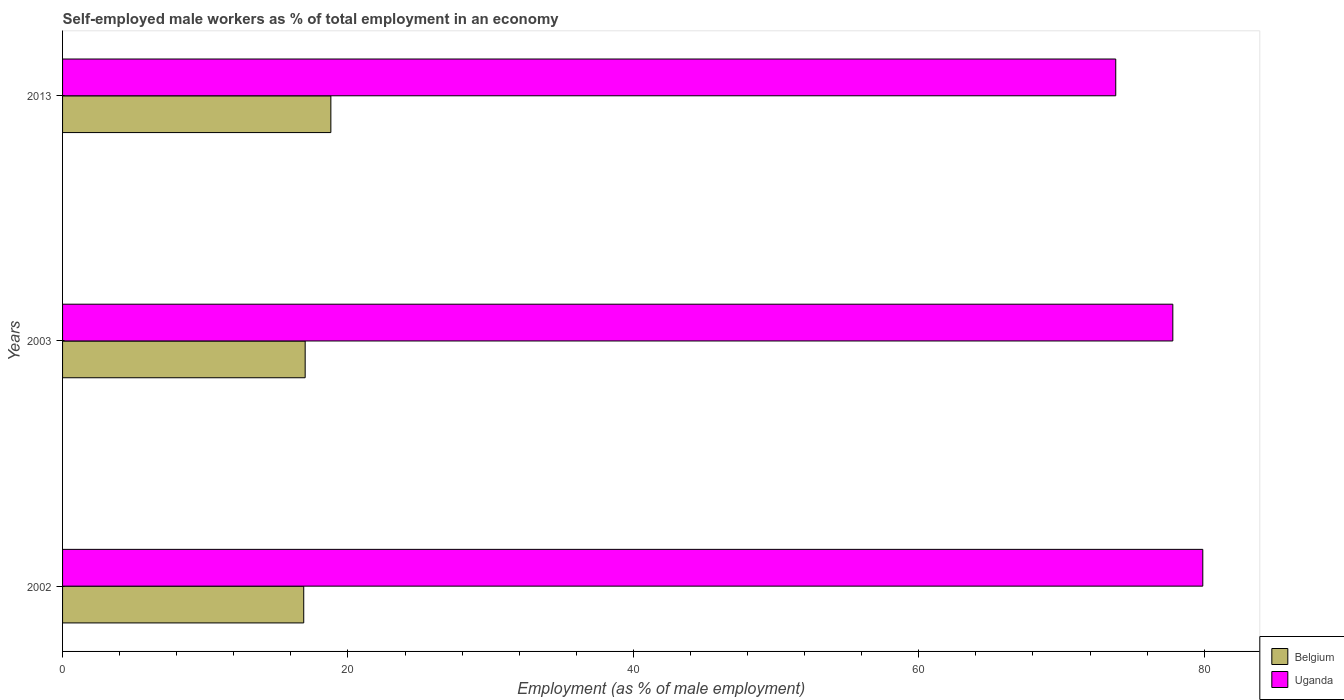How many groups of bars are there?
Ensure brevity in your answer.  3. Are the number of bars per tick equal to the number of legend labels?
Give a very brief answer. Yes. How many bars are there on the 3rd tick from the top?
Your response must be concise. 2. In how many cases, is the number of bars for a given year not equal to the number of legend labels?
Ensure brevity in your answer.  0. What is the percentage of self-employed male workers in Belgium in 2002?
Offer a terse response. 16.9. Across all years, what is the maximum percentage of self-employed male workers in Belgium?
Keep it short and to the point. 18.8. Across all years, what is the minimum percentage of self-employed male workers in Uganda?
Provide a succinct answer. 73.8. In which year was the percentage of self-employed male workers in Uganda maximum?
Offer a terse response. 2002. In which year was the percentage of self-employed male workers in Uganda minimum?
Your answer should be compact. 2013. What is the total percentage of self-employed male workers in Belgium in the graph?
Offer a very short reply. 52.7. What is the difference between the percentage of self-employed male workers in Belgium in 2003 and that in 2013?
Offer a terse response. -1.8. What is the difference between the percentage of self-employed male workers in Uganda in 2013 and the percentage of self-employed male workers in Belgium in 2002?
Make the answer very short. 56.9. What is the average percentage of self-employed male workers in Uganda per year?
Keep it short and to the point. 77.17. In the year 2003, what is the difference between the percentage of self-employed male workers in Uganda and percentage of self-employed male workers in Belgium?
Give a very brief answer. 60.8. In how many years, is the percentage of self-employed male workers in Belgium greater than 28 %?
Offer a terse response. 0. What is the ratio of the percentage of self-employed male workers in Uganda in 2003 to that in 2013?
Make the answer very short. 1.05. Is the difference between the percentage of self-employed male workers in Uganda in 2002 and 2013 greater than the difference between the percentage of self-employed male workers in Belgium in 2002 and 2013?
Keep it short and to the point. Yes. What is the difference between the highest and the second highest percentage of self-employed male workers in Uganda?
Provide a short and direct response. 2.1. What is the difference between the highest and the lowest percentage of self-employed male workers in Belgium?
Keep it short and to the point. 1.9. Is the sum of the percentage of self-employed male workers in Belgium in 2002 and 2013 greater than the maximum percentage of self-employed male workers in Uganda across all years?
Make the answer very short. No. What does the 1st bar from the top in 2013 represents?
Your answer should be compact. Uganda. What does the 2nd bar from the bottom in 2013 represents?
Offer a very short reply. Uganda. Does the graph contain any zero values?
Your answer should be compact. No. How many legend labels are there?
Offer a very short reply. 2. How are the legend labels stacked?
Keep it short and to the point. Vertical. What is the title of the graph?
Offer a terse response. Self-employed male workers as % of total employment in an economy. What is the label or title of the X-axis?
Make the answer very short. Employment (as % of male employment). What is the Employment (as % of male employment) of Belgium in 2002?
Your answer should be compact. 16.9. What is the Employment (as % of male employment) of Uganda in 2002?
Ensure brevity in your answer.  79.9. What is the Employment (as % of male employment) in Uganda in 2003?
Offer a terse response. 77.8. What is the Employment (as % of male employment) in Belgium in 2013?
Offer a terse response. 18.8. What is the Employment (as % of male employment) in Uganda in 2013?
Your response must be concise. 73.8. Across all years, what is the maximum Employment (as % of male employment) in Belgium?
Your response must be concise. 18.8. Across all years, what is the maximum Employment (as % of male employment) of Uganda?
Offer a terse response. 79.9. Across all years, what is the minimum Employment (as % of male employment) of Belgium?
Keep it short and to the point. 16.9. Across all years, what is the minimum Employment (as % of male employment) in Uganda?
Provide a short and direct response. 73.8. What is the total Employment (as % of male employment) in Belgium in the graph?
Provide a short and direct response. 52.7. What is the total Employment (as % of male employment) of Uganda in the graph?
Provide a succinct answer. 231.5. What is the difference between the Employment (as % of male employment) of Belgium in 2003 and that in 2013?
Offer a very short reply. -1.8. What is the difference between the Employment (as % of male employment) in Uganda in 2003 and that in 2013?
Your answer should be compact. 4. What is the difference between the Employment (as % of male employment) of Belgium in 2002 and the Employment (as % of male employment) of Uganda in 2003?
Provide a short and direct response. -60.9. What is the difference between the Employment (as % of male employment) of Belgium in 2002 and the Employment (as % of male employment) of Uganda in 2013?
Offer a terse response. -56.9. What is the difference between the Employment (as % of male employment) of Belgium in 2003 and the Employment (as % of male employment) of Uganda in 2013?
Offer a terse response. -56.8. What is the average Employment (as % of male employment) of Belgium per year?
Your response must be concise. 17.57. What is the average Employment (as % of male employment) in Uganda per year?
Keep it short and to the point. 77.17. In the year 2002, what is the difference between the Employment (as % of male employment) of Belgium and Employment (as % of male employment) of Uganda?
Provide a succinct answer. -63. In the year 2003, what is the difference between the Employment (as % of male employment) of Belgium and Employment (as % of male employment) of Uganda?
Your answer should be compact. -60.8. In the year 2013, what is the difference between the Employment (as % of male employment) in Belgium and Employment (as % of male employment) in Uganda?
Give a very brief answer. -55. What is the ratio of the Employment (as % of male employment) in Belgium in 2002 to that in 2003?
Your answer should be very brief. 0.99. What is the ratio of the Employment (as % of male employment) in Belgium in 2002 to that in 2013?
Offer a terse response. 0.9. What is the ratio of the Employment (as % of male employment) in Uganda in 2002 to that in 2013?
Make the answer very short. 1.08. What is the ratio of the Employment (as % of male employment) of Belgium in 2003 to that in 2013?
Your answer should be very brief. 0.9. What is the ratio of the Employment (as % of male employment) of Uganda in 2003 to that in 2013?
Offer a very short reply. 1.05. What is the difference between the highest and the lowest Employment (as % of male employment) in Uganda?
Provide a short and direct response. 6.1. 